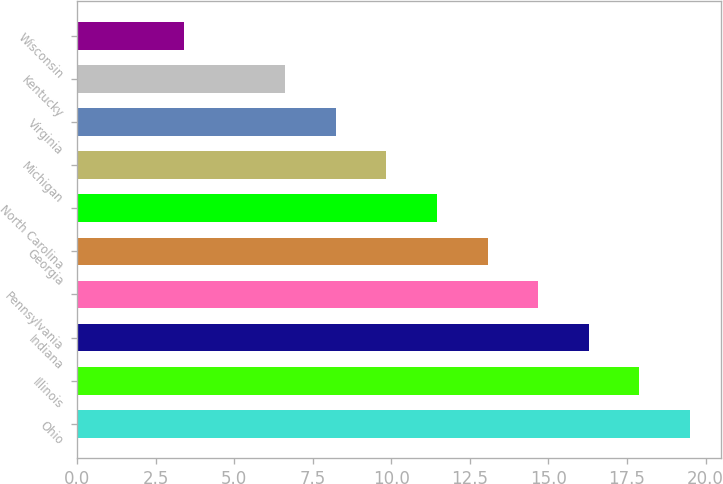Convert chart. <chart><loc_0><loc_0><loc_500><loc_500><bar_chart><fcel>Ohio<fcel>Illinois<fcel>Indiana<fcel>Pennsylvania<fcel>Georgia<fcel>North Carolina<fcel>Michigan<fcel>Virginia<fcel>Kentucky<fcel>Wisconsin<nl><fcel>19.5<fcel>17.89<fcel>16.28<fcel>14.67<fcel>13.06<fcel>11.45<fcel>9.84<fcel>8.23<fcel>6.62<fcel>3.4<nl></chart> 